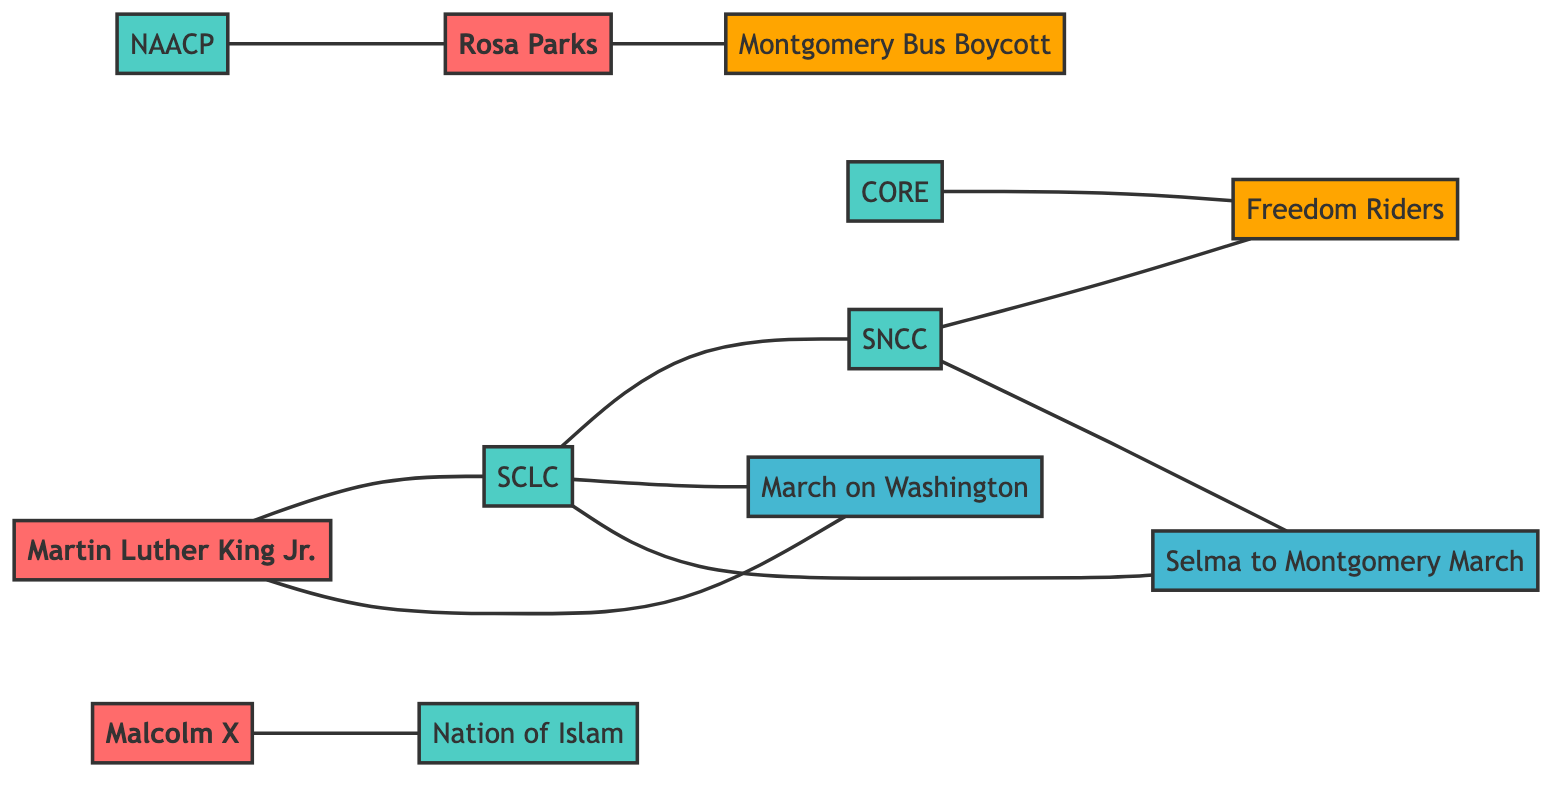What are the total number of nodes in the diagram? By counting the unique entries in the 'nodes' array, we identify that there are 12 individual nodes representing leaders, organizations, movements, and events within the graph.
Answer: 12 Which leader is connected to the SCLC? The connection from the node "Martin Luther King Jr." to the "SCLC" indicates that he has a direct linkage to this organization, as represented in the 'links' array.
Answer: Martin Luther King Jr What movement is associated with Rosa Parks? The link between "Rosa Parks" and "Montgomery Bus Boycott" shows that she directly influenced this movement, as evidenced by their relationship in the graph.
Answer: Montgomery Bus Boycott How many organizations are linked to the Freedom Riders? Examining the links associated with "Freedom Riders", we see connections to "SNCC" and "CORE," leading to a total of 2 organizations linked to this movement.
Answer: 2 What event is Martin Luther King Jr. connected to besides SCLC? The graph shows that "Martin Luther King Jr." is also connected to the "March on Washington," indicating his participation in this significant event in addition to his role with SCLC.
Answer: March on Washington Which two events are both linked to SCLC? The connections from "SCLC" to "March on Washington" and "Selma to Montgomery March" suggest that SCLC plays a role in both events within the Civil Rights Era.
Answer: March on Washington, Selma to Montgomery March Which organization is directly linked to the Nation of Islam? The diagram shows that "Malcolm X" has a direct relationship with "Nation of Islam," highlighting his association with this organization.
Answer: Malcolm X How many leaders are listed in the diagram? The 'nodes' section reveals that there are three individuals categorized as leaders: Martin Luther King Jr., Rosa Parks, and Malcolm X, providing a count of 3 leaders.
Answer: 3 Which movement is associated with SNCC? The "SNCC" node has a connecting edge to "Freedom Riders," indicating that it is directly associated with this movement within the diagram.
Answer: Freedom Riders 